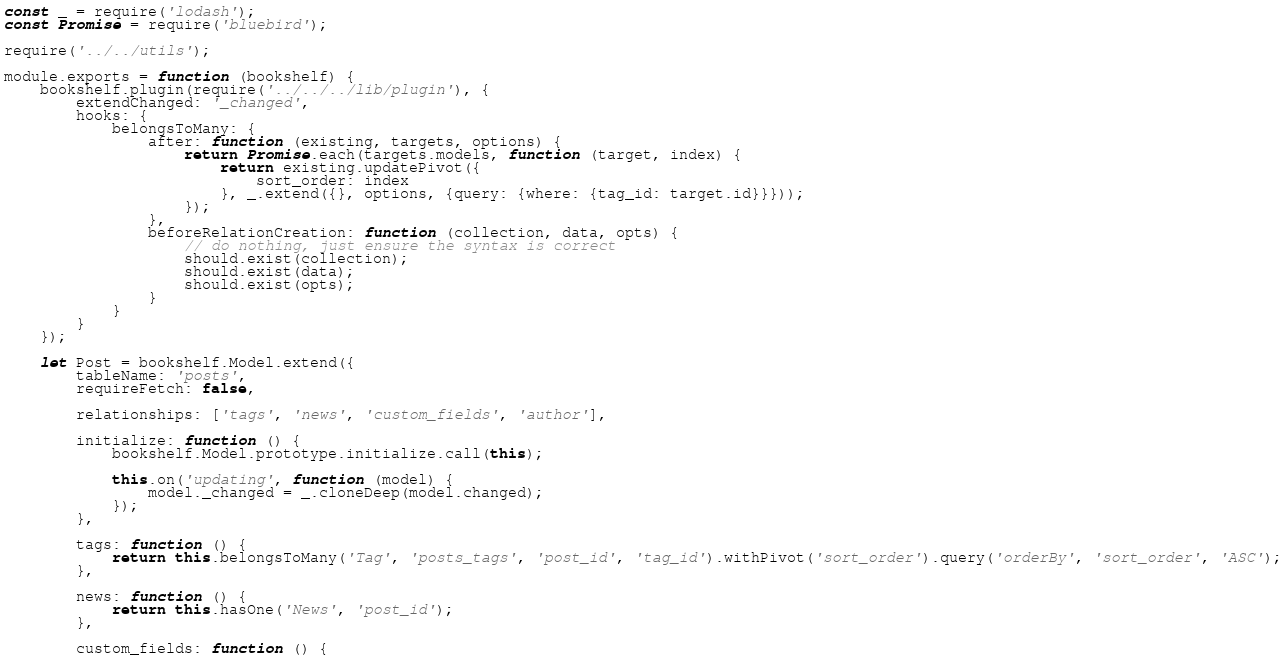<code> <loc_0><loc_0><loc_500><loc_500><_JavaScript_>const _ = require('lodash');
const Promise = require('bluebird');

require('../../utils');

module.exports = function (bookshelf) {
    bookshelf.plugin(require('../../../lib/plugin'), {
        extendChanged: '_changed',
        hooks: {
            belongsToMany: {
                after: function (existing, targets, options) {
                    return Promise.each(targets.models, function (target, index) {
                        return existing.updatePivot({
                            sort_order: index
                        }, _.extend({}, options, {query: {where: {tag_id: target.id}}}));
                    });
                },
                beforeRelationCreation: function (collection, data, opts) {
                    // do nothing, just ensure the syntax is correct
                    should.exist(collection);
                    should.exist(data);
                    should.exist(opts);
                }
            }
        }
    });

    let Post = bookshelf.Model.extend({
        tableName: 'posts',
        requireFetch: false,

        relationships: ['tags', 'news', 'custom_fields', 'author'],

        initialize: function () {
            bookshelf.Model.prototype.initialize.call(this);

            this.on('updating', function (model) {
                model._changed = _.cloneDeep(model.changed);
            });
        },

        tags: function () {
            return this.belongsToMany('Tag', 'posts_tags', 'post_id', 'tag_id').withPivot('sort_order').query('orderBy', 'sort_order', 'ASC');
        },

        news: function () {
            return this.hasOne('News', 'post_id');
        },

        custom_fields: function () {</code> 